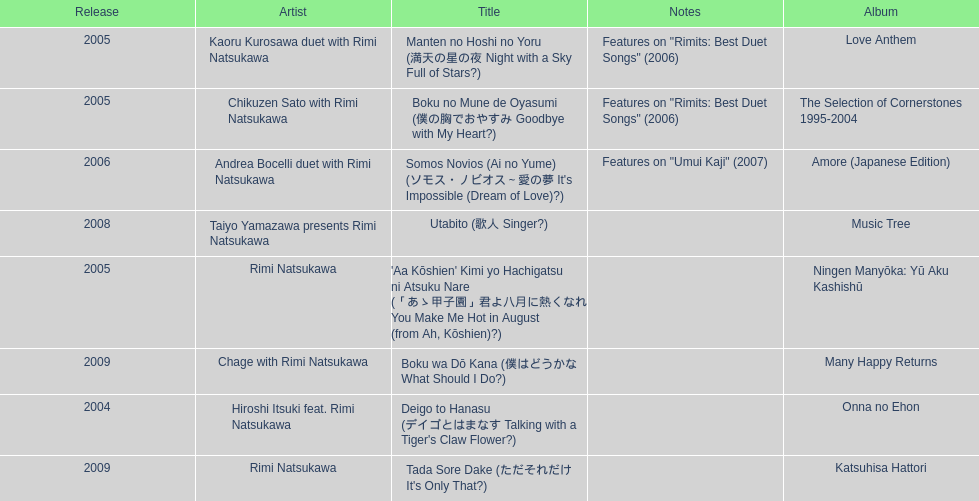What is the number of albums released with the artist rimi natsukawa? 8. 